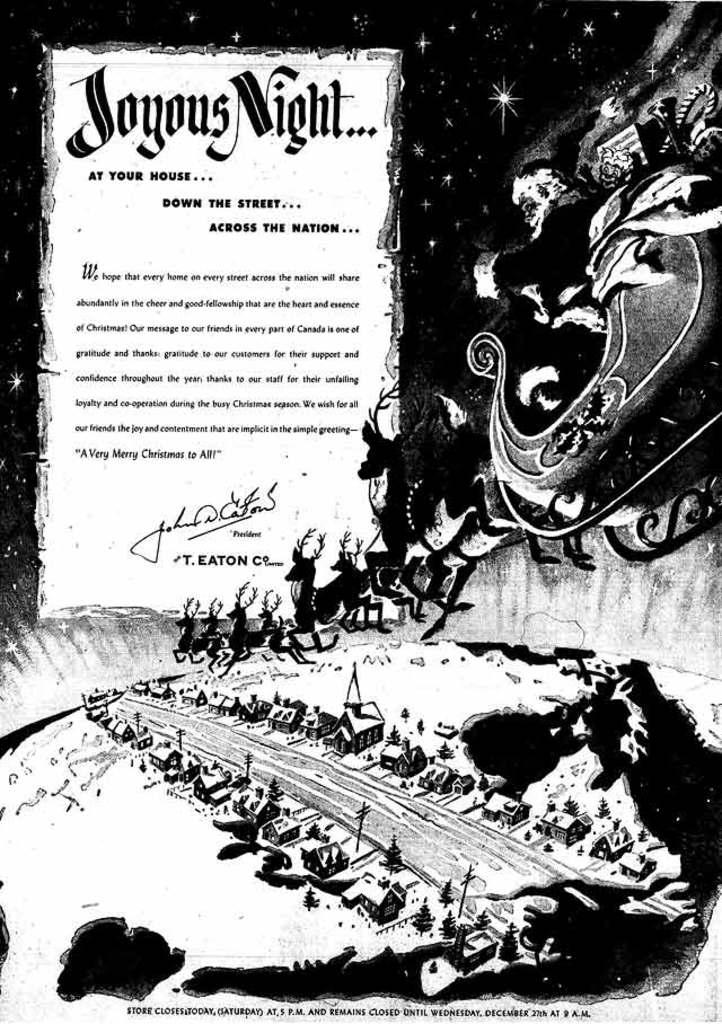<image>
Relay a brief, clear account of the picture shown. Santa Claus flying his reindeer over a city and a sign that says Joyous Night. 